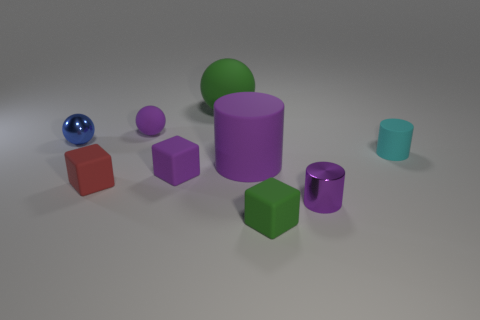Subtract all gray balls. How many purple cylinders are left? 2 Subtract all tiny red blocks. How many blocks are left? 2 Subtract 1 balls. How many balls are left? 2 Subtract all brown spheres. Subtract all red cubes. How many spheres are left? 3 Subtract all cubes. How many objects are left? 6 Subtract 1 cyan cylinders. How many objects are left? 8 Subtract all tiny red cubes. Subtract all tiny gray things. How many objects are left? 8 Add 7 green cubes. How many green cubes are left? 8 Add 4 large cyan shiny cylinders. How many large cyan shiny cylinders exist? 4 